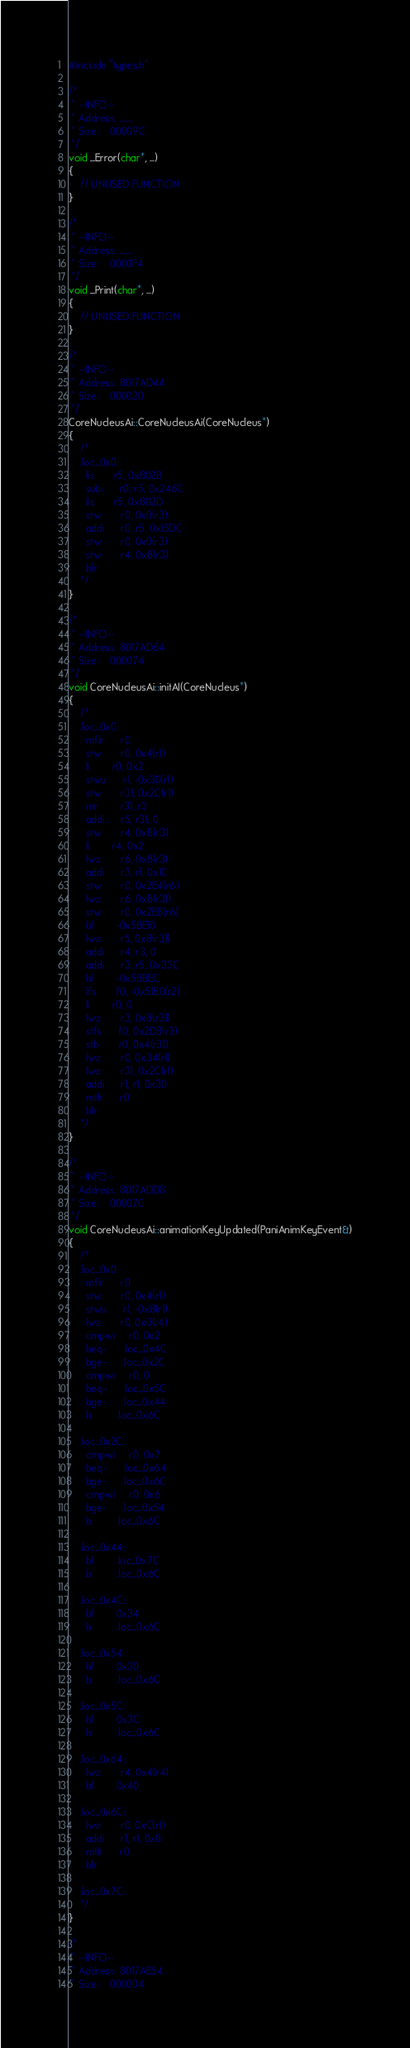Convert code to text. <code><loc_0><loc_0><loc_500><loc_500><_C++_>#include "types.h"

/*
 * --INFO--
 * Address:	........
 * Size:	00009C
 */
void _Error(char*, ...)
{
	// UNUSED FUNCTION
}

/*
 * --INFO--
 * Address:	........
 * Size:	0000F4
 */
void _Print(char*, ...)
{
	// UNUSED FUNCTION
}

/*
 * --INFO--
 * Address:	8017AD44
 * Size:	000020
 */
CoreNucleusAi::CoreNucleusAi(CoreNucleus*)
{
	/*
	.loc_0x0:
	  lis       r5, 0x802B
	  subi      r0, r5, 0x246C
	  lis       r5, 0x802D
	  stw       r0, 0x0(r3)
	  addi      r0, r5, 0x15DC
	  stw       r0, 0x0(r3)
	  stw       r4, 0x8(r3)
	  blr
	*/
}

/*
 * --INFO--
 * Address:	8017AD64
 * Size:	000074
 */
void CoreNucleusAi::initAI(CoreNucleus*)
{
	/*
	.loc_0x0:
	  mflr      r0
	  stw       r0, 0x4(r1)
	  li        r0, 0x2
	  stwu      r1, -0x30(r1)
	  stw       r31, 0x2C(r1)
	  mr        r31, r3
	  addi      r5, r31, 0
	  stw       r4, 0x8(r3)
	  li        r4, 0x2
	  lwz       r6, 0x8(r3)
	  addi      r3, r1, 0x1C
	  stw       r0, 0x2E4(r6)
	  lwz       r6, 0x8(r31)
	  stw       r0, 0x2E8(r6)
	  bl        -0x5BE10
	  lwz       r5, 0x8(r31)
	  addi      r4, r3, 0
	  addi      r3, r5, 0x33C
	  bl        -0x5BBEC
	  lfs       f0, -0x5180(r2)
	  li        r0, 0
	  lwz       r3, 0x8(r31)
	  stfs      f0, 0x2D8(r3)
	  stb       r0, 0x4(r31)
	  lwz       r0, 0x34(r1)
	  lwz       r31, 0x2C(r1)
	  addi      r1, r1, 0x30
	  mtlr      r0
	  blr
	*/
}

/*
 * --INFO--
 * Address:	8017ADD8
 * Size:	00007C
 */
void CoreNucleusAi::animationKeyUpdated(PaniAnimKeyEvent&)
{
	/*
	.loc_0x0:
	  mflr      r0
	  stw       r0, 0x4(r1)
	  stwu      r1, -0x8(r1)
	  lwz       r0, 0x0(r4)
	  cmpwi     r0, 0x2
	  beq-      .loc_0x4C
	  bge-      .loc_0x2C
	  cmpwi     r0, 0
	  beq-      .loc_0x5C
	  bge-      .loc_0x44
	  b         .loc_0x6C

	.loc_0x2C:
	  cmpwi     r0, 0x7
	  beq-      .loc_0x64
	  bge-      .loc_0x6C
	  cmpwi     r0, 0x6
	  bge-      .loc_0x54
	  b         .loc_0x6C

	.loc_0x44:
	  bl        .loc_0x7C
	  b         .loc_0x6C

	.loc_0x4C:
	  bl        0x34
	  b         .loc_0x6C

	.loc_0x54:
	  bl        0x30
	  b         .loc_0x6C

	.loc_0x5C:
	  bl        0x3C
	  b         .loc_0x6C

	.loc_0x64:
	  lwz       r4, 0x4(r4)
	  bl        0x40

	.loc_0x6C:
	  lwz       r0, 0xC(r1)
	  addi      r1, r1, 0x8
	  mtlr      r0
	  blr

	.loc_0x7C:
	*/
}

/*
 * --INFO--
 * Address:	8017AE54
 * Size:	000004</code> 